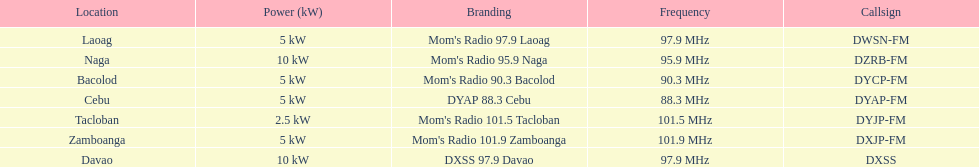Which radio has the lowest amount of mhz? DYAP 88.3 Cebu. 